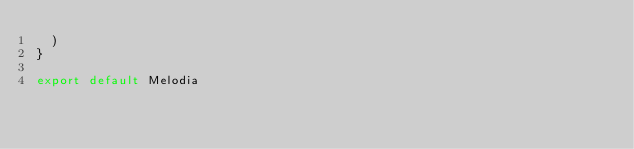Convert code to text. <code><loc_0><loc_0><loc_500><loc_500><_JavaScript_>  )
}

export default Melodia</code> 